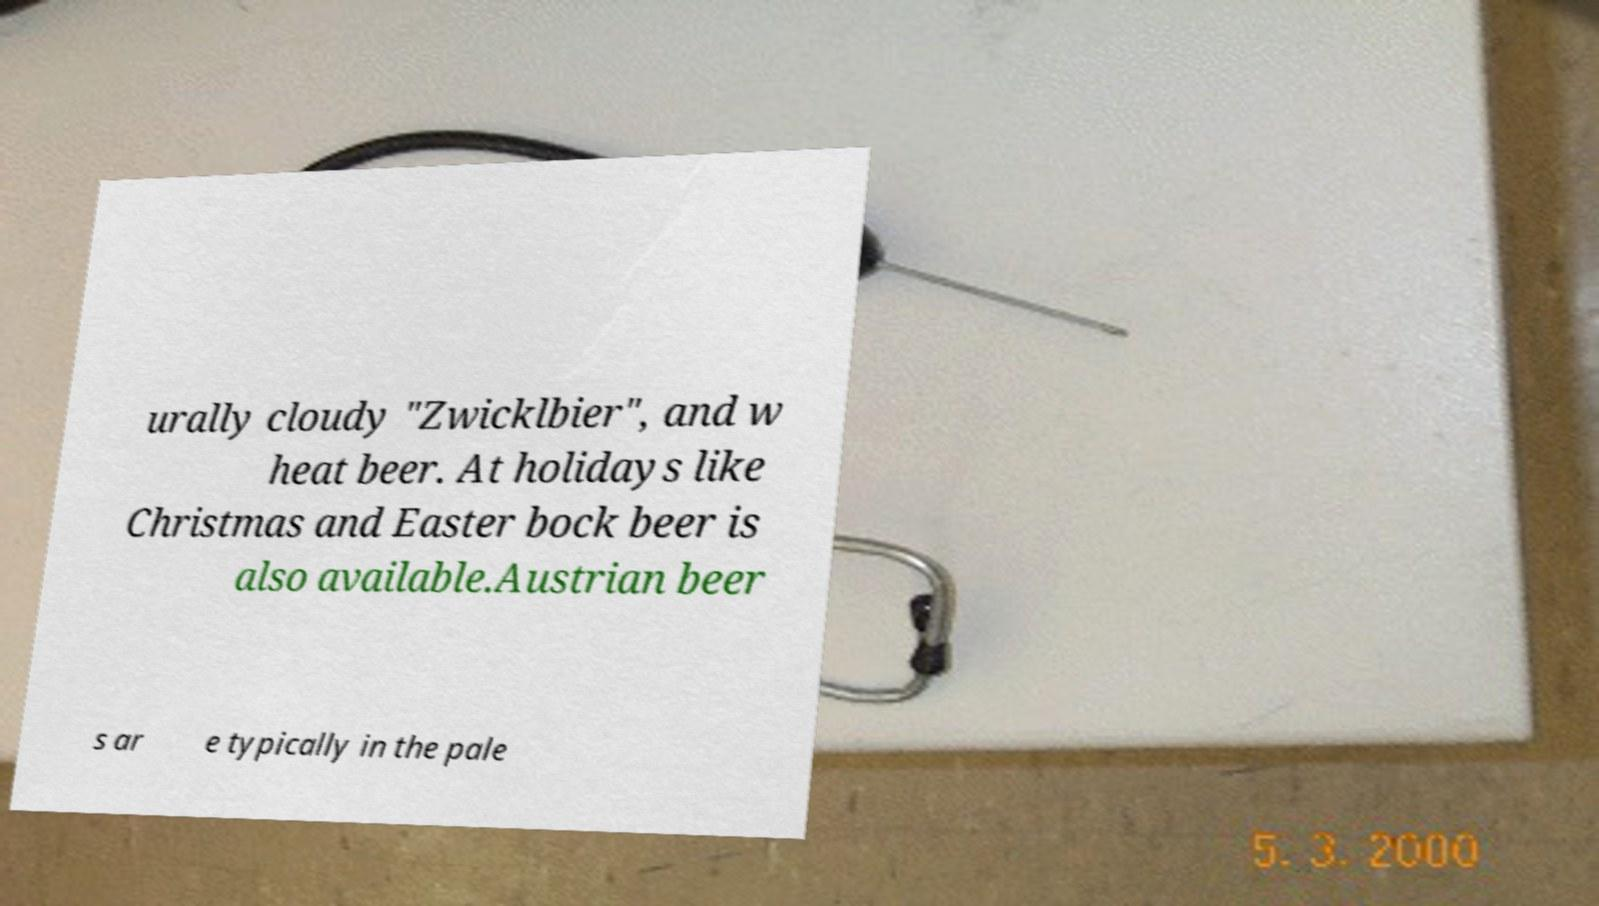Could you assist in decoding the text presented in this image and type it out clearly? urally cloudy "Zwicklbier", and w heat beer. At holidays like Christmas and Easter bock beer is also available.Austrian beer s ar e typically in the pale 